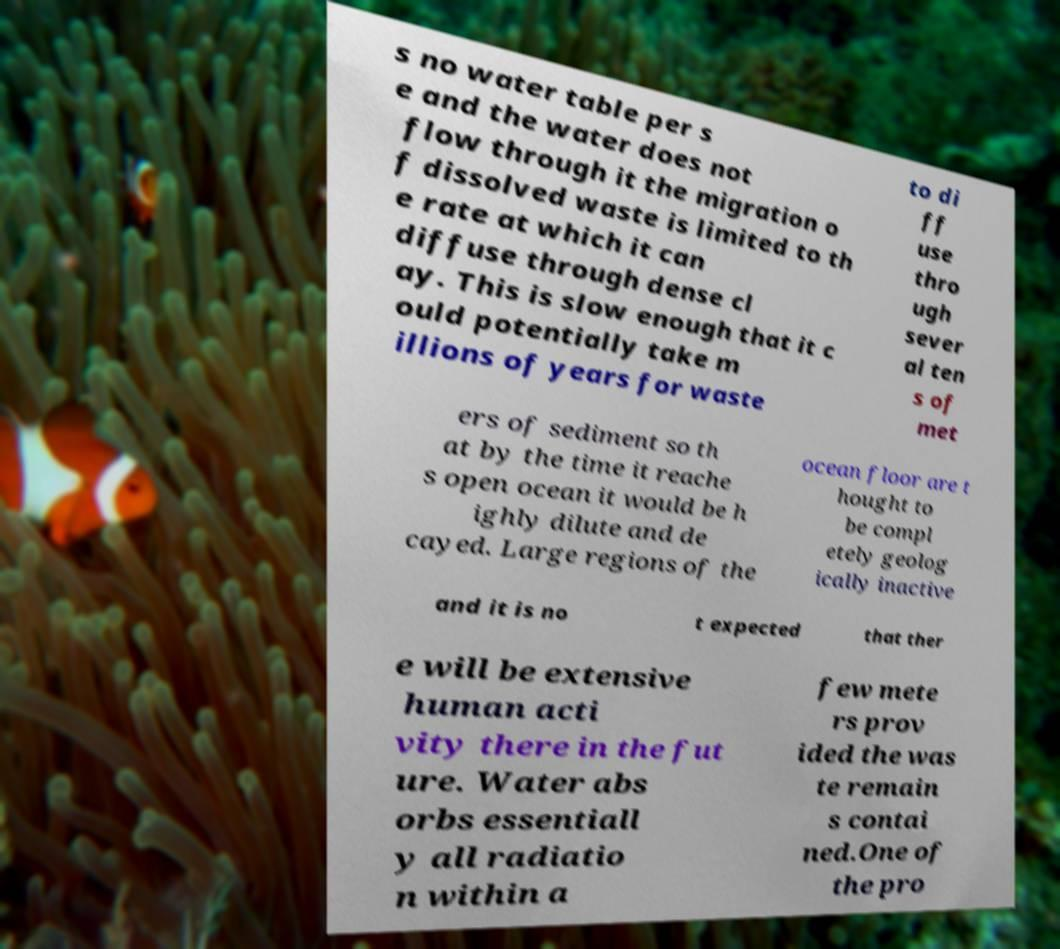I need the written content from this picture converted into text. Can you do that? s no water table per s e and the water does not flow through it the migration o f dissolved waste is limited to th e rate at which it can diffuse through dense cl ay. This is slow enough that it c ould potentially take m illions of years for waste to di ff use thro ugh sever al ten s of met ers of sediment so th at by the time it reache s open ocean it would be h ighly dilute and de cayed. Large regions of the ocean floor are t hought to be compl etely geolog ically inactive and it is no t expected that ther e will be extensive human acti vity there in the fut ure. Water abs orbs essentiall y all radiatio n within a few mete rs prov ided the was te remain s contai ned.One of the pro 